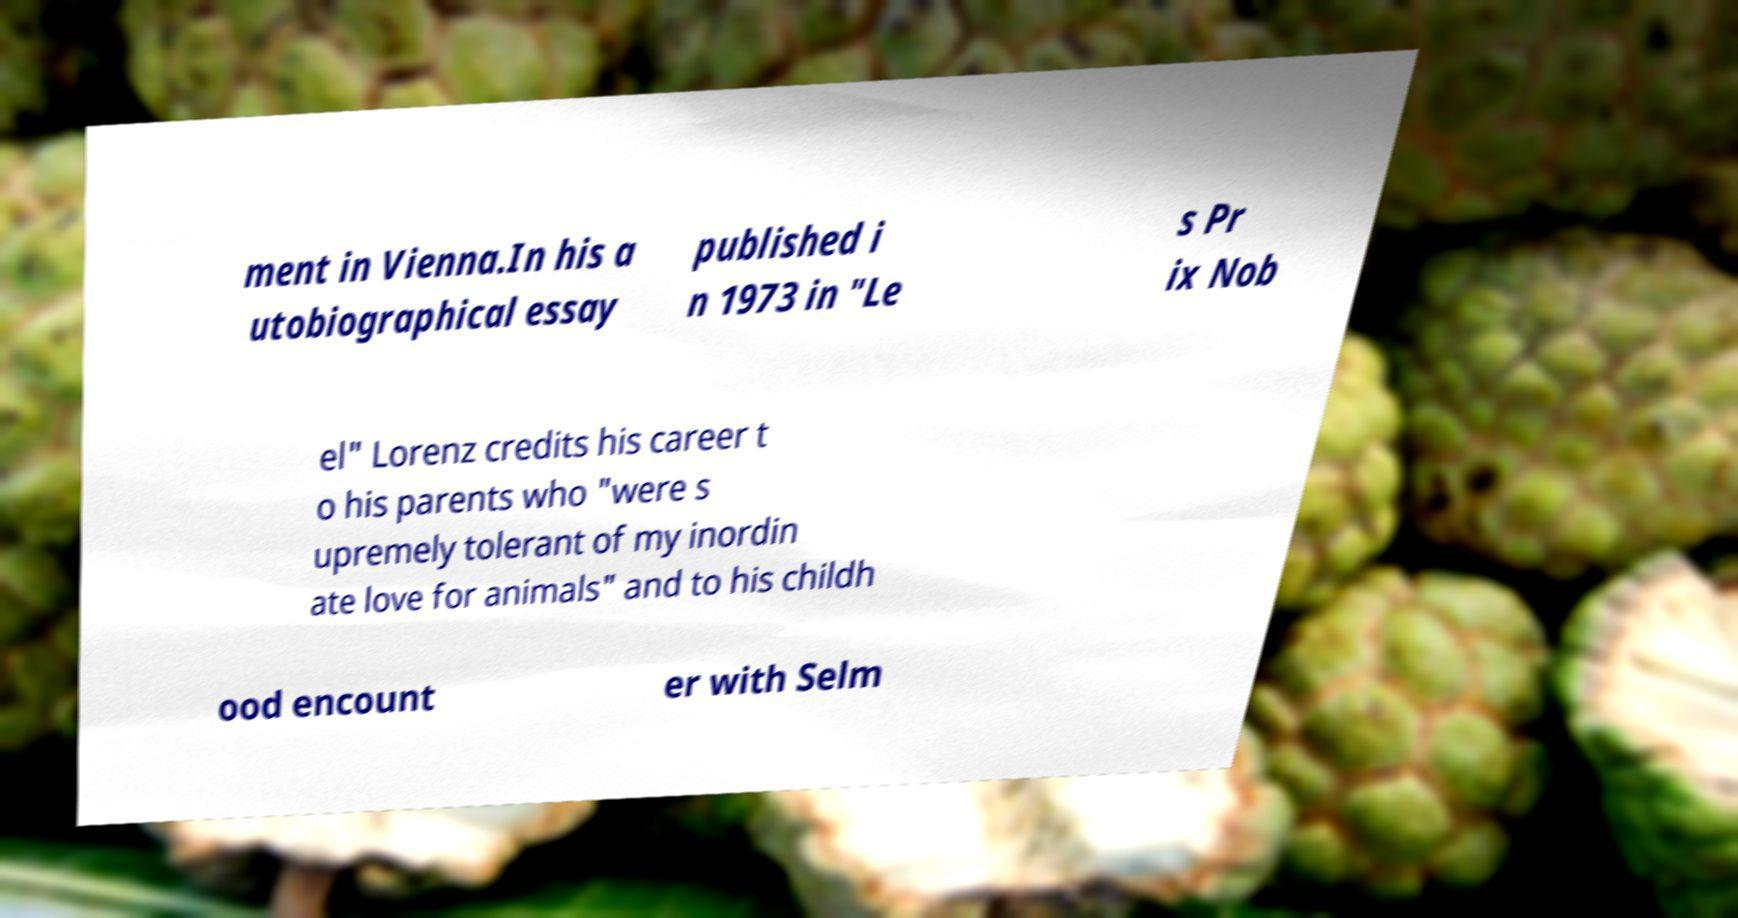Please read and relay the text visible in this image. What does it say? ment in Vienna.In his a utobiographical essay published i n 1973 in "Le s Pr ix Nob el" Lorenz credits his career t o his parents who "were s upremely tolerant of my inordin ate love for animals" and to his childh ood encount er with Selm 